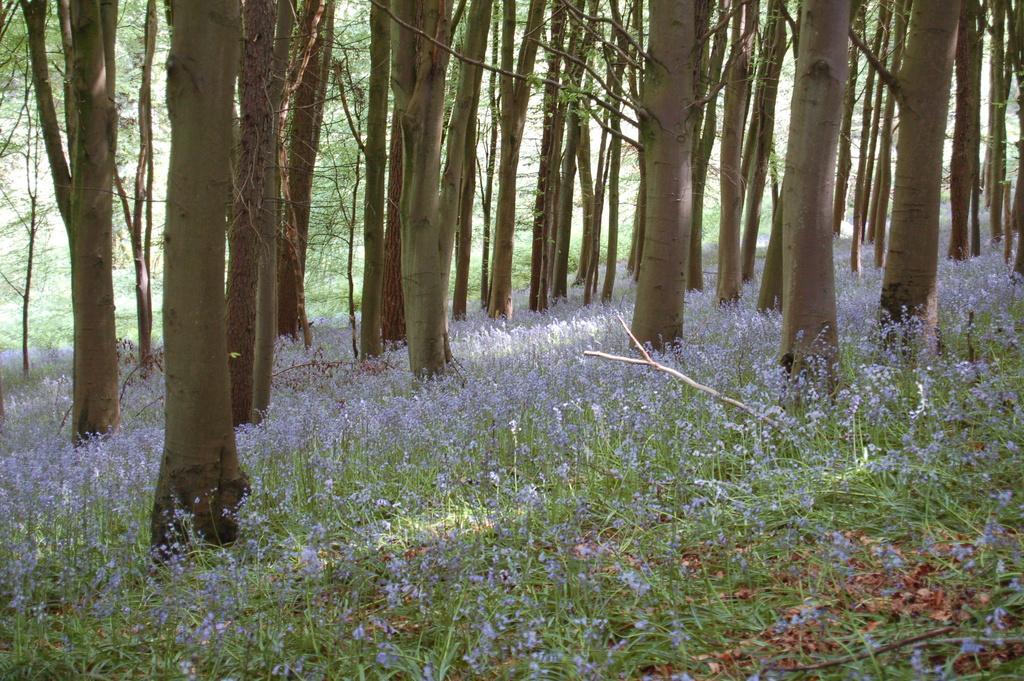Could you give a brief overview of what you see in this image? In the center of the image there are trees. At the bottom we can see grass and flowers. 